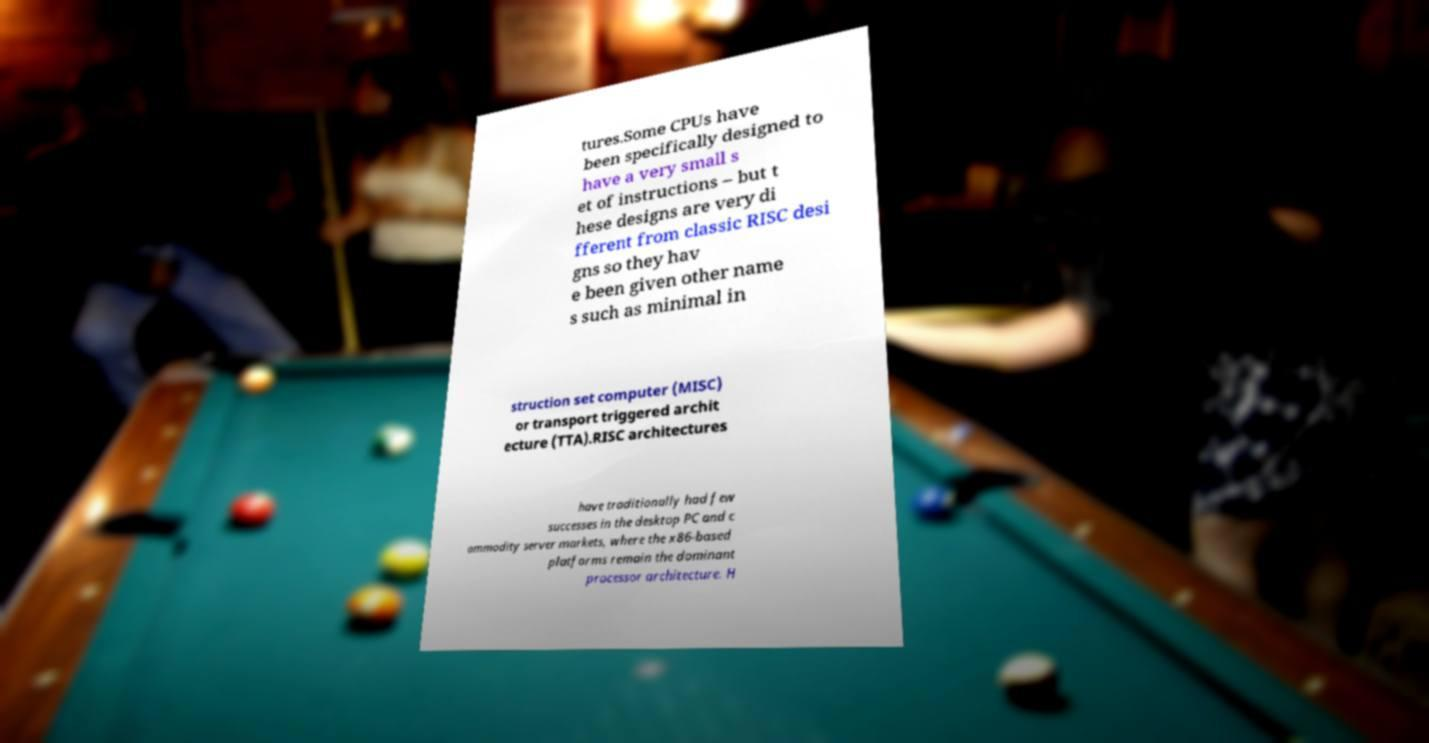For documentation purposes, I need the text within this image transcribed. Could you provide that? tures.Some CPUs have been specifically designed to have a very small s et of instructions – but t hese designs are very di fferent from classic RISC desi gns so they hav e been given other name s such as minimal in struction set computer (MISC) or transport triggered archit ecture (TTA).RISC architectures have traditionally had few successes in the desktop PC and c ommodity server markets, where the x86-based platforms remain the dominant processor architecture. H 